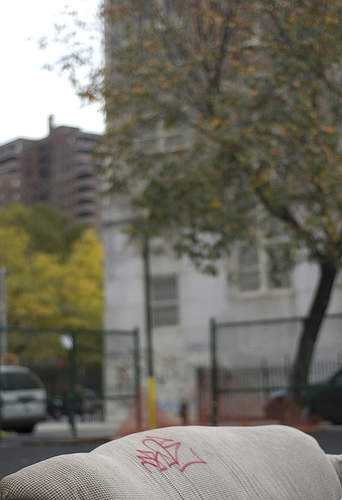<image>
Is the tree behind the building? No. The tree is not behind the building. From this viewpoint, the tree appears to be positioned elsewhere in the scene. 